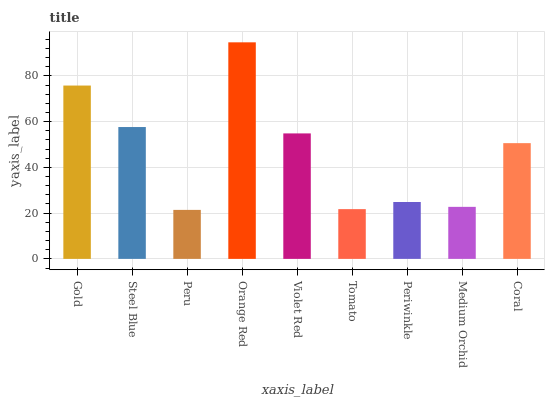Is Steel Blue the minimum?
Answer yes or no. No. Is Steel Blue the maximum?
Answer yes or no. No. Is Gold greater than Steel Blue?
Answer yes or no. Yes. Is Steel Blue less than Gold?
Answer yes or no. Yes. Is Steel Blue greater than Gold?
Answer yes or no. No. Is Gold less than Steel Blue?
Answer yes or no. No. Is Coral the high median?
Answer yes or no. Yes. Is Coral the low median?
Answer yes or no. Yes. Is Peru the high median?
Answer yes or no. No. Is Periwinkle the low median?
Answer yes or no. No. 